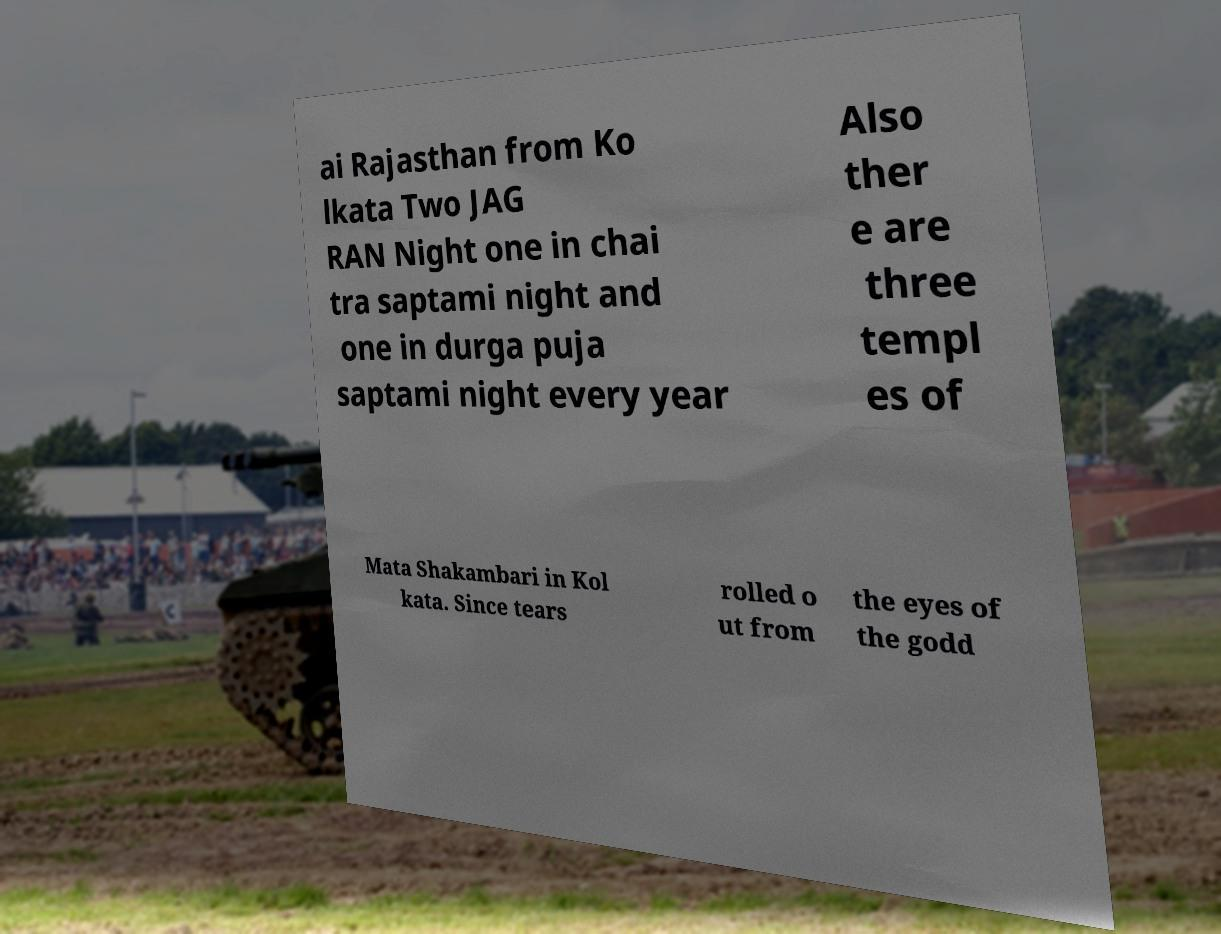Could you assist in decoding the text presented in this image and type it out clearly? ai Rajasthan from Ko lkata Two JAG RAN Night one in chai tra saptami night and one in durga puja saptami night every year Also ther e are three templ es of Mata Shakambari in Kol kata. Since tears rolled o ut from the eyes of the godd 